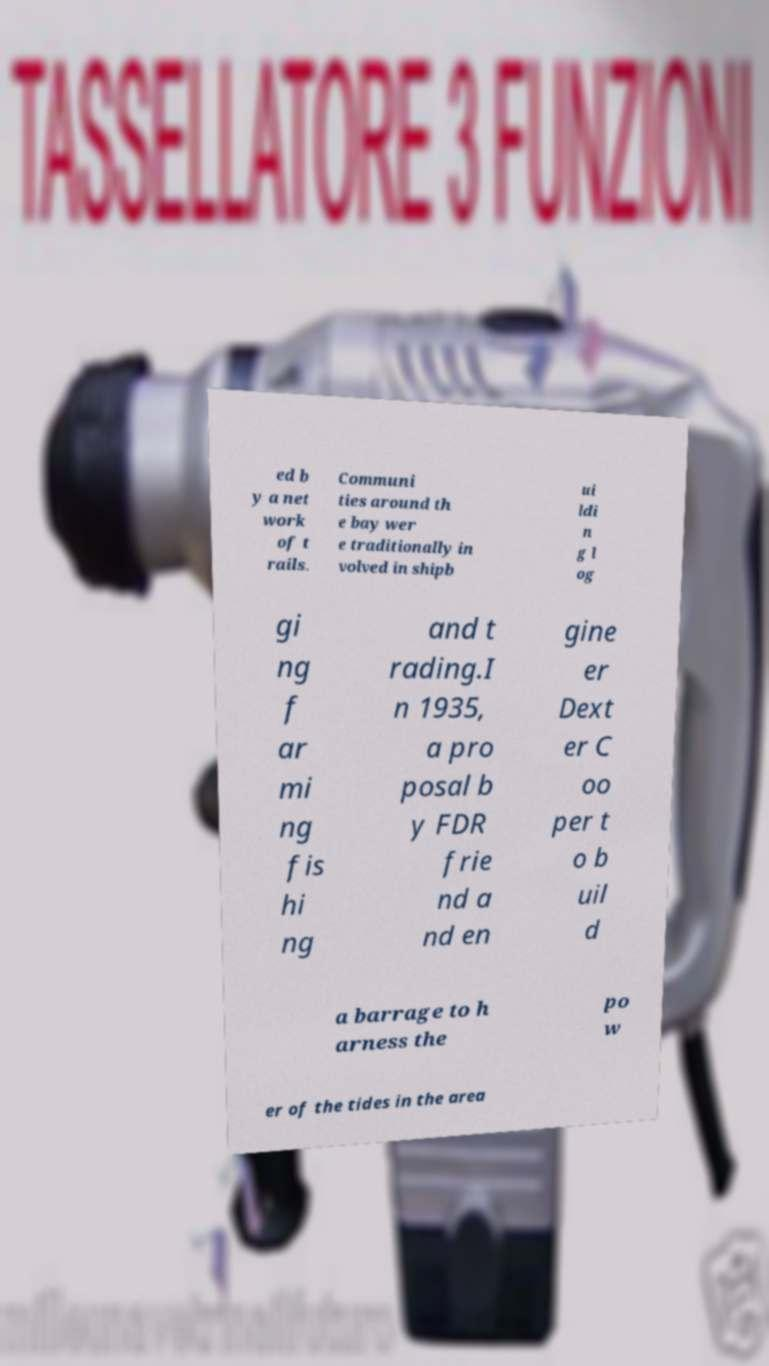For documentation purposes, I need the text within this image transcribed. Could you provide that? ed b y a net work of t rails. Communi ties around th e bay wer e traditionally in volved in shipb ui ldi n g l og gi ng f ar mi ng fis hi ng and t rading.I n 1935, a pro posal b y FDR frie nd a nd en gine er Dext er C oo per t o b uil d a barrage to h arness the po w er of the tides in the area 